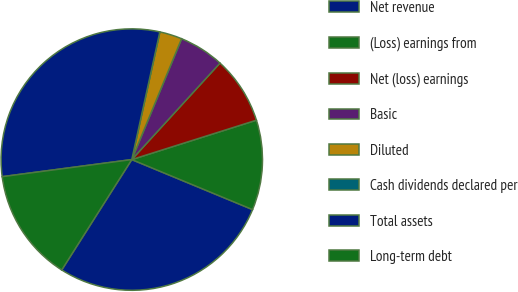Convert chart to OTSL. <chart><loc_0><loc_0><loc_500><loc_500><pie_chart><fcel>Net revenue<fcel>(Loss) earnings from<fcel>Net (loss) earnings<fcel>Basic<fcel>Diluted<fcel>Cash dividends declared per<fcel>Total assets<fcel>Long-term debt<nl><fcel>27.75%<fcel>11.12%<fcel>8.34%<fcel>5.56%<fcel>2.78%<fcel>0.0%<fcel>30.53%<fcel>13.91%<nl></chart> 